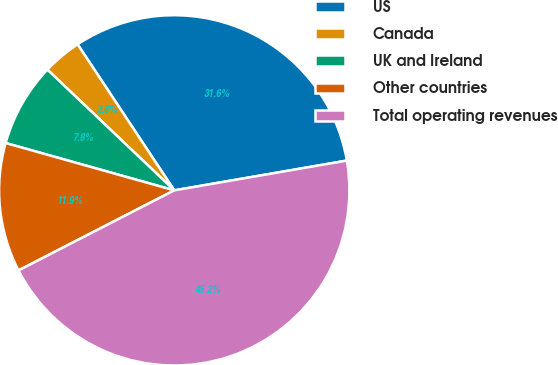Convert chart to OTSL. <chart><loc_0><loc_0><loc_500><loc_500><pie_chart><fcel>US<fcel>Canada<fcel>UK and Ireland<fcel>Other countries<fcel>Total operating revenues<nl><fcel>31.58%<fcel>3.59%<fcel>7.75%<fcel>11.91%<fcel>45.16%<nl></chart> 